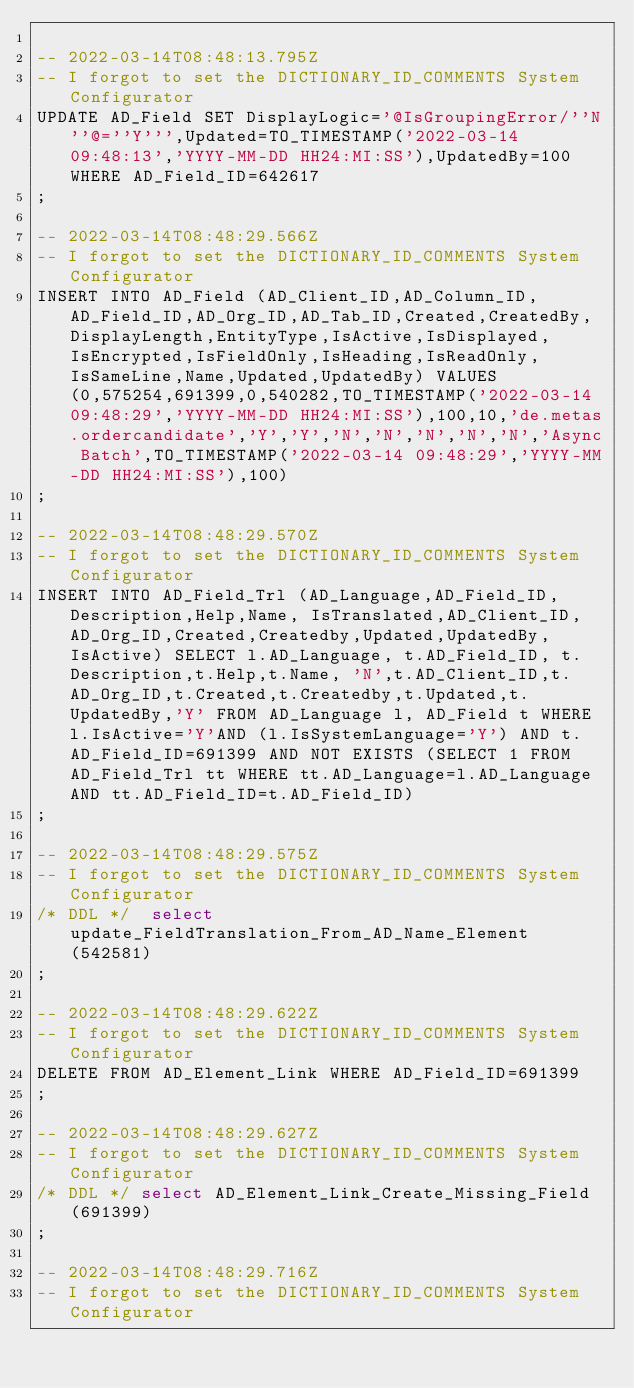<code> <loc_0><loc_0><loc_500><loc_500><_SQL_>
-- 2022-03-14T08:48:13.795Z
-- I forgot to set the DICTIONARY_ID_COMMENTS System Configurator
UPDATE AD_Field SET DisplayLogic='@IsGroupingError/''N''@=''Y''',Updated=TO_TIMESTAMP('2022-03-14 09:48:13','YYYY-MM-DD HH24:MI:SS'),UpdatedBy=100 WHERE AD_Field_ID=642617
;

-- 2022-03-14T08:48:29.566Z
-- I forgot to set the DICTIONARY_ID_COMMENTS System Configurator
INSERT INTO AD_Field (AD_Client_ID,AD_Column_ID,AD_Field_ID,AD_Org_ID,AD_Tab_ID,Created,CreatedBy,DisplayLength,EntityType,IsActive,IsDisplayed,IsEncrypted,IsFieldOnly,IsHeading,IsReadOnly,IsSameLine,Name,Updated,UpdatedBy) VALUES (0,575254,691399,0,540282,TO_TIMESTAMP('2022-03-14 09:48:29','YYYY-MM-DD HH24:MI:SS'),100,10,'de.metas.ordercandidate','Y','Y','N','N','N','N','N','Async Batch',TO_TIMESTAMP('2022-03-14 09:48:29','YYYY-MM-DD HH24:MI:SS'),100)
;

-- 2022-03-14T08:48:29.570Z
-- I forgot to set the DICTIONARY_ID_COMMENTS System Configurator
INSERT INTO AD_Field_Trl (AD_Language,AD_Field_ID, Description,Help,Name, IsTranslated,AD_Client_ID,AD_Org_ID,Created,Createdby,Updated,UpdatedBy,IsActive) SELECT l.AD_Language, t.AD_Field_ID, t.Description,t.Help,t.Name, 'N',t.AD_Client_ID,t.AD_Org_ID,t.Created,t.Createdby,t.Updated,t.UpdatedBy,'Y' FROM AD_Language l, AD_Field t WHERE l.IsActive='Y'AND (l.IsSystemLanguage='Y') AND t.AD_Field_ID=691399 AND NOT EXISTS (SELECT 1 FROM AD_Field_Trl tt WHERE tt.AD_Language=l.AD_Language AND tt.AD_Field_ID=t.AD_Field_ID)
;

-- 2022-03-14T08:48:29.575Z
-- I forgot to set the DICTIONARY_ID_COMMENTS System Configurator
/* DDL */  select update_FieldTranslation_From_AD_Name_Element(542581) 
;

-- 2022-03-14T08:48:29.622Z
-- I forgot to set the DICTIONARY_ID_COMMENTS System Configurator
DELETE FROM AD_Element_Link WHERE AD_Field_ID=691399
;

-- 2022-03-14T08:48:29.627Z
-- I forgot to set the DICTIONARY_ID_COMMENTS System Configurator
/* DDL */ select AD_Element_Link_Create_Missing_Field(691399)
;

-- 2022-03-14T08:48:29.716Z
-- I forgot to set the DICTIONARY_ID_COMMENTS System Configurator</code> 